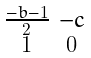<formula> <loc_0><loc_0><loc_500><loc_500>\begin{smallmatrix} \frac { - b - 1 } { 2 } & - c \\ 1 & 0 \end{smallmatrix}</formula> 